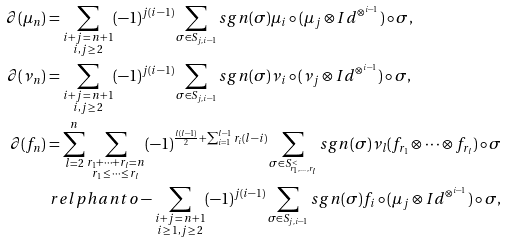<formula> <loc_0><loc_0><loc_500><loc_500>\partial ( \mu _ { n } ) & = \sum _ { \substack { i + j \, = \, n + 1 \\ i , j \, \geq \, 2 } } ( - 1 ) ^ { j ( i - 1 ) } \sum _ { \sigma \in S _ { j , i - 1 } } s g n ( \sigma ) \mu _ { i } \circ ( \mu _ { j } \otimes I d ^ { \otimes ^ { i - 1 } } ) \circ \sigma , \\ \partial ( \nu _ { n } ) & = \sum _ { \substack { i + j \, = \, n + 1 \\ i , j \, \geq \, 2 } } ( - 1 ) ^ { j ( i - 1 ) } \sum _ { \sigma \in S _ { j , i - 1 } } s g n ( \sigma ) \nu _ { i } \circ ( \nu _ { j } \otimes I d ^ { \otimes ^ { i - 1 } } ) \circ \sigma , \\ \partial ( f _ { n } ) & = \sum _ { l = 2 } ^ { n } \sum _ { \substack { r _ { 1 } + \cdots + r _ { l } = n \\ r _ { 1 } \, \leq \, \cdots \, \leq \, r _ { l } } } ( - 1 ) ^ { \frac { l ( l - 1 ) } { 2 } + \sum _ { i = 1 } ^ { l - 1 } r _ { i } ( l - i ) } \sum _ { \sigma \in S ^ { < } _ { r _ { 1 } , \dots , r _ { l } } } s g n ( \sigma ) \nu _ { l } ( f _ { r _ { 1 } } \otimes \cdots \otimes f _ { r _ { l } } ) \circ \sigma \\ & \ r e l p h a n t o - \sum _ { \substack { i + j \, = \, n + 1 \\ i \, \geq \, 1 , j \, \geq \, 2 } } ( - 1 ) ^ { j ( i - 1 ) } \sum _ { \sigma \in S _ { j , i - 1 } } s g n ( \sigma ) f _ { i } \circ ( \mu _ { j } \otimes I d ^ { \otimes ^ { i - 1 } } ) \circ \sigma ,</formula> 